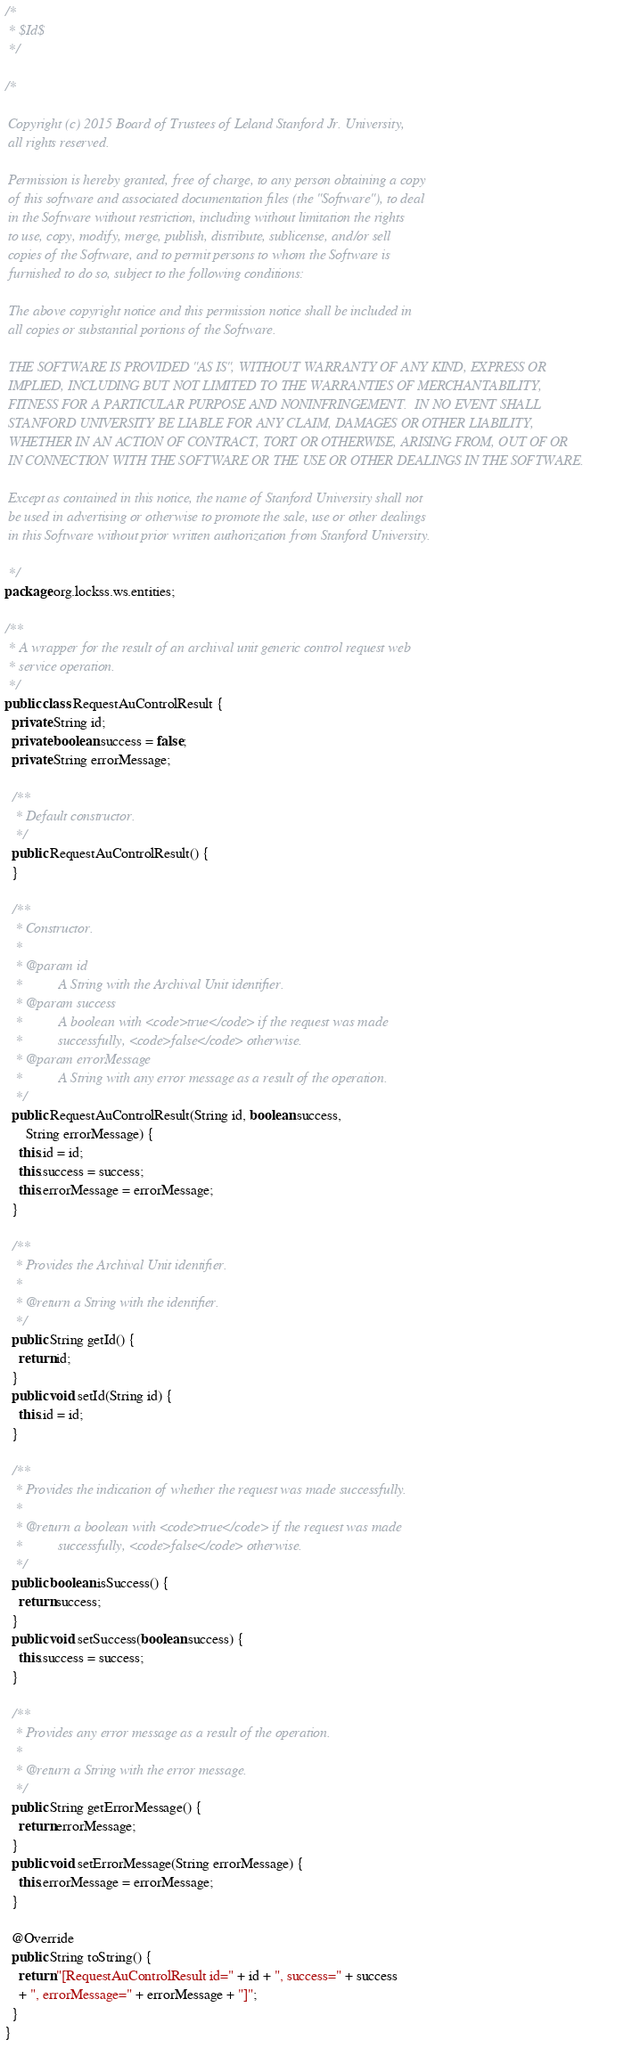Convert code to text. <code><loc_0><loc_0><loc_500><loc_500><_Java_>/*
 * $Id$
 */

/*

 Copyright (c) 2015 Board of Trustees of Leland Stanford Jr. University,
 all rights reserved.

 Permission is hereby granted, free of charge, to any person obtaining a copy
 of this software and associated documentation files (the "Software"), to deal
 in the Software without restriction, including without limitation the rights
 to use, copy, modify, merge, publish, distribute, sublicense, and/or sell
 copies of the Software, and to permit persons to whom the Software is
 furnished to do so, subject to the following conditions:

 The above copyright notice and this permission notice shall be included in
 all copies or substantial portions of the Software.

 THE SOFTWARE IS PROVIDED "AS IS", WITHOUT WARRANTY OF ANY KIND, EXPRESS OR
 IMPLIED, INCLUDING BUT NOT LIMITED TO THE WARRANTIES OF MERCHANTABILITY,
 FITNESS FOR A PARTICULAR PURPOSE AND NONINFRINGEMENT.  IN NO EVENT SHALL
 STANFORD UNIVERSITY BE LIABLE FOR ANY CLAIM, DAMAGES OR OTHER LIABILITY,
 WHETHER IN AN ACTION OF CONTRACT, TORT OR OTHERWISE, ARISING FROM, OUT OF OR
 IN CONNECTION WITH THE SOFTWARE OR THE USE OR OTHER DEALINGS IN THE SOFTWARE.

 Except as contained in this notice, the name of Stanford University shall not
 be used in advertising or otherwise to promote the sale, use or other dealings
 in this Software without prior written authorization from Stanford University.

 */
package org.lockss.ws.entities;

/**
 * A wrapper for the result of an archival unit generic control request web
 * service operation.
 */
public class RequestAuControlResult {
  private String id;
  private boolean success = false;
  private String errorMessage;

  /**
   * Default constructor.
   */
  public RequestAuControlResult() {
  }

  /**
   * Constructor.
   * 
   * @param id
   *          A String with the Archival Unit identifier.
   * @param success
   *          A boolean with <code>true</code> if the request was made
   *          successfully, <code>false</code> otherwise.
   * @param errorMessage
   *          A String with any error message as a result of the operation.
   */
  public RequestAuControlResult(String id, boolean success,
      String errorMessage) {
    this.id = id;
    this.success = success;
    this.errorMessage = errorMessage;
  }

  /**
   * Provides the Archival Unit identifier.
   * 
   * @return a String with the identifier.
   */
  public String getId() {
    return id;
  }
  public void setId(String id) {
    this.id = id;
  }

  /**
   * Provides the indication of whether the request was made successfully.
   * 
   * @return a boolean with <code>true</code> if the request was made
   *          successfully, <code>false</code> otherwise.
   */
  public boolean isSuccess() {
    return success;
  }
  public void setSuccess(boolean success) {
    this.success = success;
  }

  /**
   * Provides any error message as a result of the operation.
   * 
   * @return a String with the error message.
   */
  public String getErrorMessage() {
    return errorMessage;
  }
  public void setErrorMessage(String errorMessage) {
    this.errorMessage = errorMessage;
  }

  @Override
  public String toString() {
    return "[RequestAuControlResult id=" + id + ", success=" + success
	+ ", errorMessage=" + errorMessage + "]";
  }
}
</code> 